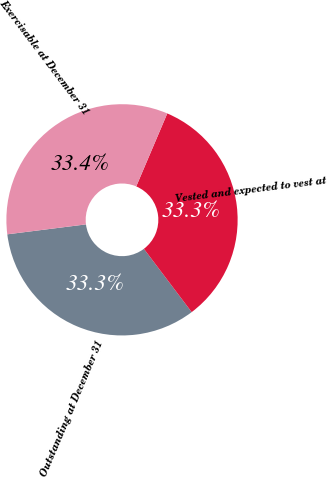Convert chart. <chart><loc_0><loc_0><loc_500><loc_500><pie_chart><fcel>Outstanding at December 31<fcel>Vested and expected to vest at<fcel>Exercisable at December 31<nl><fcel>33.29%<fcel>33.3%<fcel>33.4%<nl></chart> 